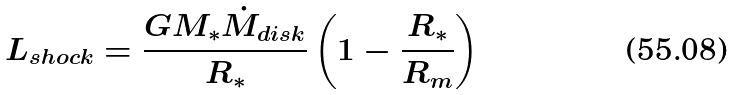<formula> <loc_0><loc_0><loc_500><loc_500>L _ { s h o c k } = \frac { G M _ { * } \dot { M } _ { d i s k } } { R _ { * } } \left ( 1 - \frac { R _ { * } } { R _ { m } } \right )</formula> 